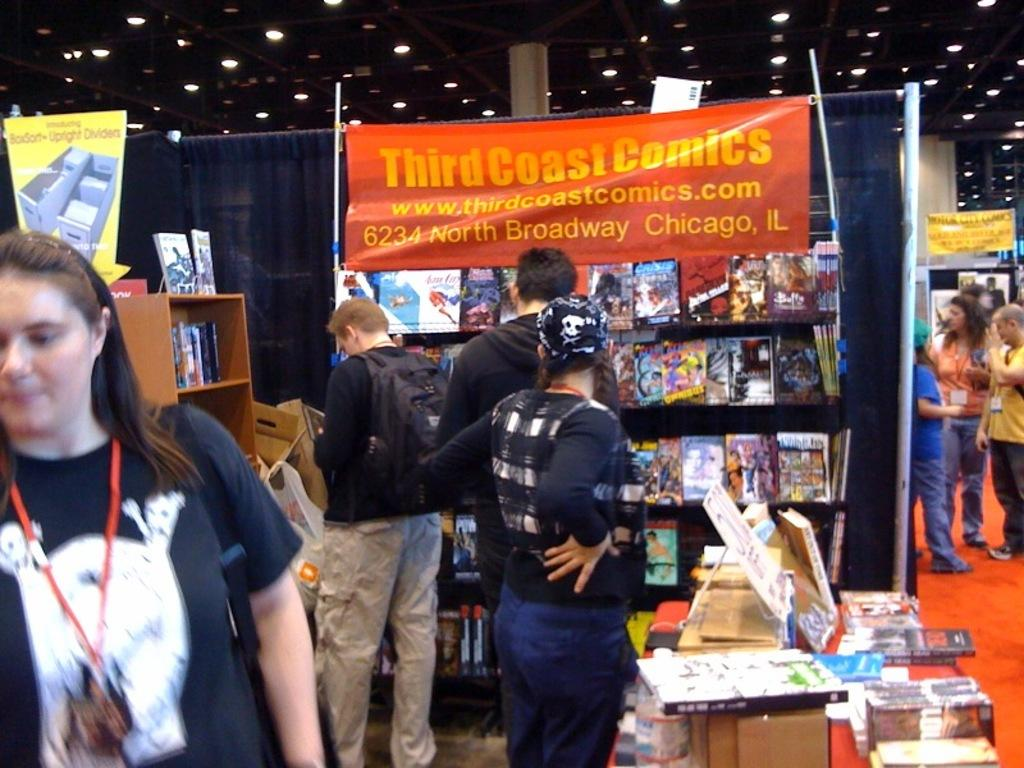What type of event is the image from? The image is from an exhibition. What can be seen in the background of the image? There are people standing in front of book racks. What color is the floor in the image? The floor is red. What is the source of light in the image? There are lights on the ceiling. How many fingers can be seen on the person's hand in the image? There is no specific person's hand visible in the image, so it is not possible to determine the number of fingers. 